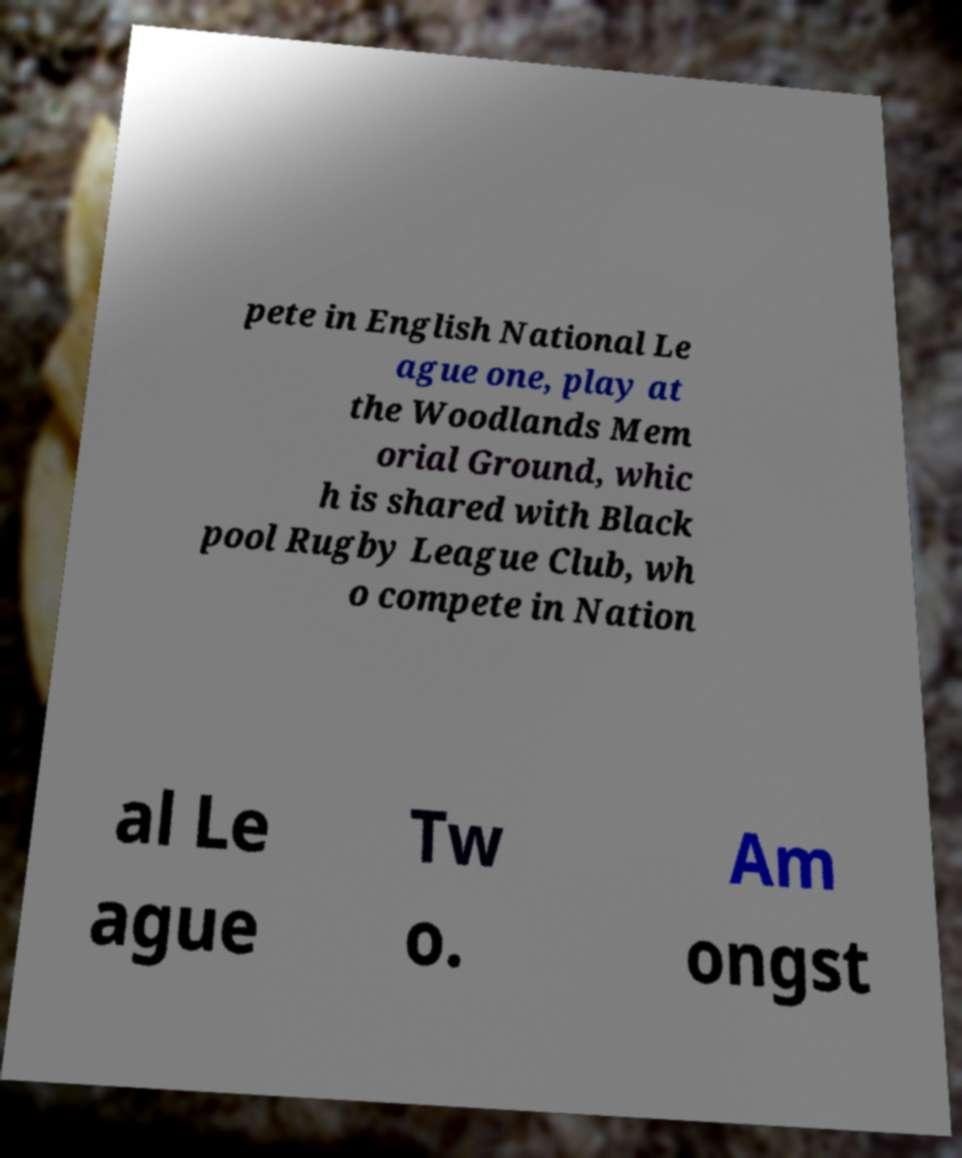Please identify and transcribe the text found in this image. pete in English National Le ague one, play at the Woodlands Mem orial Ground, whic h is shared with Black pool Rugby League Club, wh o compete in Nation al Le ague Tw o. Am ongst 